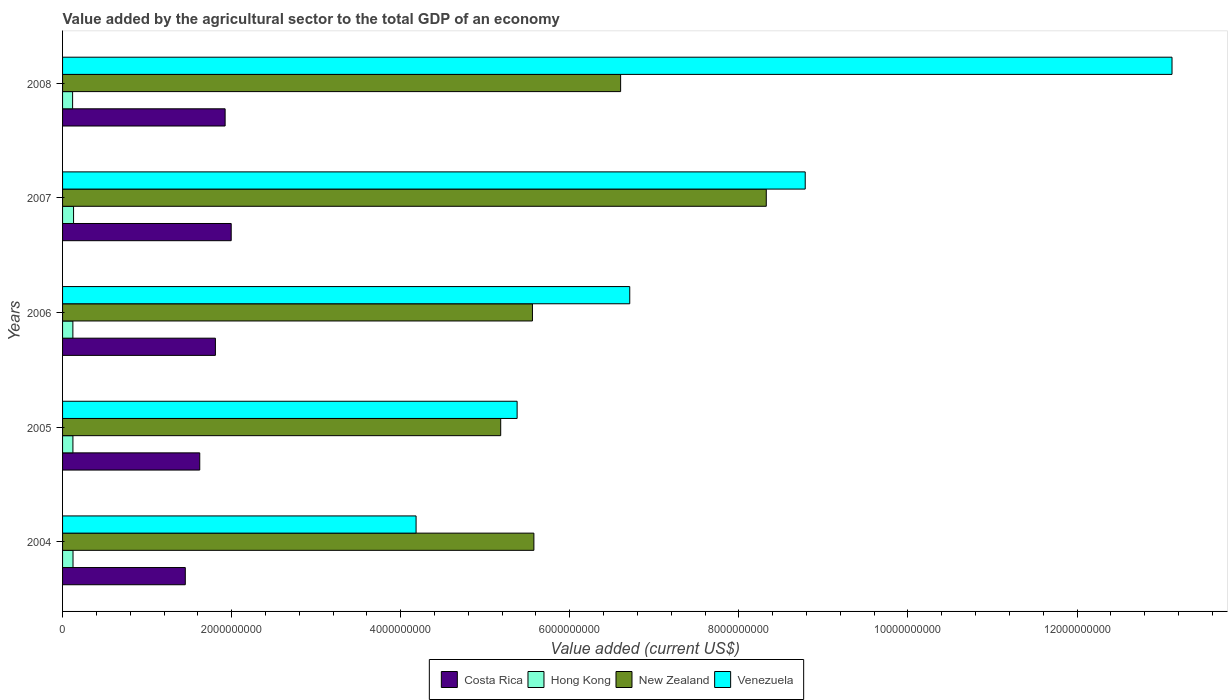Are the number of bars per tick equal to the number of legend labels?
Make the answer very short. Yes. Are the number of bars on each tick of the Y-axis equal?
Make the answer very short. Yes. How many bars are there on the 4th tick from the bottom?
Give a very brief answer. 4. What is the label of the 4th group of bars from the top?
Provide a short and direct response. 2005. What is the value added by the agricultural sector to the total GDP in Venezuela in 2008?
Make the answer very short. 1.31e+1. Across all years, what is the maximum value added by the agricultural sector to the total GDP in Hong Kong?
Your response must be concise. 1.30e+08. Across all years, what is the minimum value added by the agricultural sector to the total GDP in Hong Kong?
Keep it short and to the point. 1.19e+08. In which year was the value added by the agricultural sector to the total GDP in Costa Rica maximum?
Your answer should be very brief. 2007. In which year was the value added by the agricultural sector to the total GDP in Hong Kong minimum?
Your answer should be compact. 2008. What is the total value added by the agricultural sector to the total GDP in Venezuela in the graph?
Ensure brevity in your answer.  3.82e+1. What is the difference between the value added by the agricultural sector to the total GDP in Hong Kong in 2006 and that in 2007?
Keep it short and to the point. -8.19e+06. What is the difference between the value added by the agricultural sector to the total GDP in Costa Rica in 2004 and the value added by the agricultural sector to the total GDP in Venezuela in 2006?
Provide a short and direct response. -5.26e+09. What is the average value added by the agricultural sector to the total GDP in Costa Rica per year?
Your response must be concise. 1.76e+09. In the year 2007, what is the difference between the value added by the agricultural sector to the total GDP in Costa Rica and value added by the agricultural sector to the total GDP in Venezuela?
Your answer should be very brief. -6.79e+09. What is the ratio of the value added by the agricultural sector to the total GDP in Venezuela in 2004 to that in 2006?
Your response must be concise. 0.62. Is the value added by the agricultural sector to the total GDP in Costa Rica in 2006 less than that in 2007?
Give a very brief answer. Yes. What is the difference between the highest and the second highest value added by the agricultural sector to the total GDP in Venezuela?
Provide a succinct answer. 4.34e+09. What is the difference between the highest and the lowest value added by the agricultural sector to the total GDP in Hong Kong?
Ensure brevity in your answer.  1.13e+07. In how many years, is the value added by the agricultural sector to the total GDP in Costa Rica greater than the average value added by the agricultural sector to the total GDP in Costa Rica taken over all years?
Your response must be concise. 3. What does the 1st bar from the top in 2004 represents?
Your response must be concise. Venezuela. Are all the bars in the graph horizontal?
Keep it short and to the point. Yes. Does the graph contain grids?
Offer a very short reply. No. Where does the legend appear in the graph?
Offer a very short reply. Bottom center. How many legend labels are there?
Offer a terse response. 4. What is the title of the graph?
Provide a succinct answer. Value added by the agricultural sector to the total GDP of an economy. What is the label or title of the X-axis?
Your answer should be compact. Value added (current US$). What is the label or title of the Y-axis?
Offer a very short reply. Years. What is the Value added (current US$) of Costa Rica in 2004?
Give a very brief answer. 1.45e+09. What is the Value added (current US$) of Hong Kong in 2004?
Give a very brief answer. 1.24e+08. What is the Value added (current US$) in New Zealand in 2004?
Give a very brief answer. 5.58e+09. What is the Value added (current US$) of Venezuela in 2004?
Your answer should be very brief. 4.18e+09. What is the Value added (current US$) in Costa Rica in 2005?
Offer a terse response. 1.62e+09. What is the Value added (current US$) in Hong Kong in 2005?
Your answer should be compact. 1.23e+08. What is the Value added (current US$) of New Zealand in 2005?
Your answer should be compact. 5.18e+09. What is the Value added (current US$) of Venezuela in 2005?
Ensure brevity in your answer.  5.38e+09. What is the Value added (current US$) in Costa Rica in 2006?
Give a very brief answer. 1.81e+09. What is the Value added (current US$) of Hong Kong in 2006?
Your response must be concise. 1.22e+08. What is the Value added (current US$) in New Zealand in 2006?
Give a very brief answer. 5.56e+09. What is the Value added (current US$) of Venezuela in 2006?
Provide a succinct answer. 6.71e+09. What is the Value added (current US$) in Costa Rica in 2007?
Provide a short and direct response. 1.99e+09. What is the Value added (current US$) in Hong Kong in 2007?
Your answer should be very brief. 1.30e+08. What is the Value added (current US$) in New Zealand in 2007?
Give a very brief answer. 8.32e+09. What is the Value added (current US$) of Venezuela in 2007?
Your answer should be compact. 8.79e+09. What is the Value added (current US$) in Costa Rica in 2008?
Give a very brief answer. 1.92e+09. What is the Value added (current US$) in Hong Kong in 2008?
Ensure brevity in your answer.  1.19e+08. What is the Value added (current US$) of New Zealand in 2008?
Ensure brevity in your answer.  6.60e+09. What is the Value added (current US$) in Venezuela in 2008?
Provide a short and direct response. 1.31e+1. Across all years, what is the maximum Value added (current US$) in Costa Rica?
Your response must be concise. 1.99e+09. Across all years, what is the maximum Value added (current US$) in Hong Kong?
Your response must be concise. 1.30e+08. Across all years, what is the maximum Value added (current US$) in New Zealand?
Keep it short and to the point. 8.32e+09. Across all years, what is the maximum Value added (current US$) in Venezuela?
Offer a terse response. 1.31e+1. Across all years, what is the minimum Value added (current US$) in Costa Rica?
Offer a terse response. 1.45e+09. Across all years, what is the minimum Value added (current US$) in Hong Kong?
Give a very brief answer. 1.19e+08. Across all years, what is the minimum Value added (current US$) of New Zealand?
Your response must be concise. 5.18e+09. Across all years, what is the minimum Value added (current US$) in Venezuela?
Offer a terse response. 4.18e+09. What is the total Value added (current US$) of Costa Rica in the graph?
Your answer should be compact. 8.80e+09. What is the total Value added (current US$) in Hong Kong in the graph?
Keep it short and to the point. 6.17e+08. What is the total Value added (current US$) of New Zealand in the graph?
Offer a terse response. 3.12e+1. What is the total Value added (current US$) in Venezuela in the graph?
Your answer should be compact. 3.82e+1. What is the difference between the Value added (current US$) in Costa Rica in 2004 and that in 2005?
Ensure brevity in your answer.  -1.71e+08. What is the difference between the Value added (current US$) of Hong Kong in 2004 and that in 2005?
Ensure brevity in your answer.  1.12e+06. What is the difference between the Value added (current US$) of New Zealand in 2004 and that in 2005?
Your response must be concise. 3.93e+08. What is the difference between the Value added (current US$) in Venezuela in 2004 and that in 2005?
Ensure brevity in your answer.  -1.20e+09. What is the difference between the Value added (current US$) in Costa Rica in 2004 and that in 2006?
Provide a succinct answer. -3.56e+08. What is the difference between the Value added (current US$) in Hong Kong in 2004 and that in 2006?
Make the answer very short. 1.74e+06. What is the difference between the Value added (current US$) of New Zealand in 2004 and that in 2006?
Provide a short and direct response. 1.70e+07. What is the difference between the Value added (current US$) of Venezuela in 2004 and that in 2006?
Provide a succinct answer. -2.53e+09. What is the difference between the Value added (current US$) in Costa Rica in 2004 and that in 2007?
Give a very brief answer. -5.43e+08. What is the difference between the Value added (current US$) of Hong Kong in 2004 and that in 2007?
Offer a terse response. -6.45e+06. What is the difference between the Value added (current US$) of New Zealand in 2004 and that in 2007?
Make the answer very short. -2.75e+09. What is the difference between the Value added (current US$) of Venezuela in 2004 and that in 2007?
Keep it short and to the point. -4.60e+09. What is the difference between the Value added (current US$) in Costa Rica in 2004 and that in 2008?
Make the answer very short. -4.71e+08. What is the difference between the Value added (current US$) of Hong Kong in 2004 and that in 2008?
Your response must be concise. 4.86e+06. What is the difference between the Value added (current US$) in New Zealand in 2004 and that in 2008?
Offer a very short reply. -1.03e+09. What is the difference between the Value added (current US$) in Venezuela in 2004 and that in 2008?
Give a very brief answer. -8.94e+09. What is the difference between the Value added (current US$) of Costa Rica in 2005 and that in 2006?
Provide a succinct answer. -1.85e+08. What is the difference between the Value added (current US$) in Hong Kong in 2005 and that in 2006?
Offer a very short reply. 6.23e+05. What is the difference between the Value added (current US$) in New Zealand in 2005 and that in 2006?
Ensure brevity in your answer.  -3.76e+08. What is the difference between the Value added (current US$) in Venezuela in 2005 and that in 2006?
Make the answer very short. -1.33e+09. What is the difference between the Value added (current US$) of Costa Rica in 2005 and that in 2007?
Ensure brevity in your answer.  -3.72e+08. What is the difference between the Value added (current US$) of Hong Kong in 2005 and that in 2007?
Offer a terse response. -7.57e+06. What is the difference between the Value added (current US$) of New Zealand in 2005 and that in 2007?
Keep it short and to the point. -3.14e+09. What is the difference between the Value added (current US$) of Venezuela in 2005 and that in 2007?
Offer a terse response. -3.41e+09. What is the difference between the Value added (current US$) of Costa Rica in 2005 and that in 2008?
Keep it short and to the point. -3.00e+08. What is the difference between the Value added (current US$) in Hong Kong in 2005 and that in 2008?
Give a very brief answer. 3.75e+06. What is the difference between the Value added (current US$) of New Zealand in 2005 and that in 2008?
Provide a succinct answer. -1.42e+09. What is the difference between the Value added (current US$) in Venezuela in 2005 and that in 2008?
Your answer should be compact. -7.75e+09. What is the difference between the Value added (current US$) of Costa Rica in 2006 and that in 2007?
Keep it short and to the point. -1.87e+08. What is the difference between the Value added (current US$) of Hong Kong in 2006 and that in 2007?
Keep it short and to the point. -8.19e+06. What is the difference between the Value added (current US$) of New Zealand in 2006 and that in 2007?
Provide a short and direct response. -2.77e+09. What is the difference between the Value added (current US$) of Venezuela in 2006 and that in 2007?
Make the answer very short. -2.08e+09. What is the difference between the Value added (current US$) in Costa Rica in 2006 and that in 2008?
Make the answer very short. -1.15e+08. What is the difference between the Value added (current US$) in Hong Kong in 2006 and that in 2008?
Your answer should be compact. 3.12e+06. What is the difference between the Value added (current US$) in New Zealand in 2006 and that in 2008?
Your response must be concise. -1.04e+09. What is the difference between the Value added (current US$) in Venezuela in 2006 and that in 2008?
Your answer should be very brief. -6.41e+09. What is the difference between the Value added (current US$) of Costa Rica in 2007 and that in 2008?
Provide a succinct answer. 7.20e+07. What is the difference between the Value added (current US$) of Hong Kong in 2007 and that in 2008?
Offer a very short reply. 1.13e+07. What is the difference between the Value added (current US$) in New Zealand in 2007 and that in 2008?
Offer a very short reply. 1.72e+09. What is the difference between the Value added (current US$) of Venezuela in 2007 and that in 2008?
Your response must be concise. -4.34e+09. What is the difference between the Value added (current US$) in Costa Rica in 2004 and the Value added (current US$) in Hong Kong in 2005?
Keep it short and to the point. 1.33e+09. What is the difference between the Value added (current US$) in Costa Rica in 2004 and the Value added (current US$) in New Zealand in 2005?
Provide a succinct answer. -3.73e+09. What is the difference between the Value added (current US$) of Costa Rica in 2004 and the Value added (current US$) of Venezuela in 2005?
Provide a short and direct response. -3.93e+09. What is the difference between the Value added (current US$) of Hong Kong in 2004 and the Value added (current US$) of New Zealand in 2005?
Offer a terse response. -5.06e+09. What is the difference between the Value added (current US$) in Hong Kong in 2004 and the Value added (current US$) in Venezuela in 2005?
Offer a very short reply. -5.25e+09. What is the difference between the Value added (current US$) in New Zealand in 2004 and the Value added (current US$) in Venezuela in 2005?
Ensure brevity in your answer.  1.98e+08. What is the difference between the Value added (current US$) of Costa Rica in 2004 and the Value added (current US$) of Hong Kong in 2006?
Offer a terse response. 1.33e+09. What is the difference between the Value added (current US$) in Costa Rica in 2004 and the Value added (current US$) in New Zealand in 2006?
Keep it short and to the point. -4.11e+09. What is the difference between the Value added (current US$) of Costa Rica in 2004 and the Value added (current US$) of Venezuela in 2006?
Your answer should be very brief. -5.26e+09. What is the difference between the Value added (current US$) in Hong Kong in 2004 and the Value added (current US$) in New Zealand in 2006?
Ensure brevity in your answer.  -5.43e+09. What is the difference between the Value added (current US$) of Hong Kong in 2004 and the Value added (current US$) of Venezuela in 2006?
Give a very brief answer. -6.59e+09. What is the difference between the Value added (current US$) of New Zealand in 2004 and the Value added (current US$) of Venezuela in 2006?
Keep it short and to the point. -1.13e+09. What is the difference between the Value added (current US$) in Costa Rica in 2004 and the Value added (current US$) in Hong Kong in 2007?
Offer a terse response. 1.32e+09. What is the difference between the Value added (current US$) in Costa Rica in 2004 and the Value added (current US$) in New Zealand in 2007?
Make the answer very short. -6.87e+09. What is the difference between the Value added (current US$) of Costa Rica in 2004 and the Value added (current US$) of Venezuela in 2007?
Give a very brief answer. -7.33e+09. What is the difference between the Value added (current US$) in Hong Kong in 2004 and the Value added (current US$) in New Zealand in 2007?
Offer a terse response. -8.20e+09. What is the difference between the Value added (current US$) in Hong Kong in 2004 and the Value added (current US$) in Venezuela in 2007?
Provide a short and direct response. -8.66e+09. What is the difference between the Value added (current US$) of New Zealand in 2004 and the Value added (current US$) of Venezuela in 2007?
Provide a short and direct response. -3.21e+09. What is the difference between the Value added (current US$) in Costa Rica in 2004 and the Value added (current US$) in Hong Kong in 2008?
Offer a terse response. 1.33e+09. What is the difference between the Value added (current US$) of Costa Rica in 2004 and the Value added (current US$) of New Zealand in 2008?
Your answer should be compact. -5.15e+09. What is the difference between the Value added (current US$) in Costa Rica in 2004 and the Value added (current US$) in Venezuela in 2008?
Your response must be concise. -1.17e+1. What is the difference between the Value added (current US$) of Hong Kong in 2004 and the Value added (current US$) of New Zealand in 2008?
Make the answer very short. -6.48e+09. What is the difference between the Value added (current US$) in Hong Kong in 2004 and the Value added (current US$) in Venezuela in 2008?
Give a very brief answer. -1.30e+1. What is the difference between the Value added (current US$) in New Zealand in 2004 and the Value added (current US$) in Venezuela in 2008?
Keep it short and to the point. -7.55e+09. What is the difference between the Value added (current US$) of Costa Rica in 2005 and the Value added (current US$) of Hong Kong in 2006?
Your answer should be very brief. 1.50e+09. What is the difference between the Value added (current US$) of Costa Rica in 2005 and the Value added (current US$) of New Zealand in 2006?
Offer a very short reply. -3.94e+09. What is the difference between the Value added (current US$) in Costa Rica in 2005 and the Value added (current US$) in Venezuela in 2006?
Your answer should be very brief. -5.09e+09. What is the difference between the Value added (current US$) of Hong Kong in 2005 and the Value added (current US$) of New Zealand in 2006?
Your answer should be very brief. -5.44e+09. What is the difference between the Value added (current US$) of Hong Kong in 2005 and the Value added (current US$) of Venezuela in 2006?
Offer a terse response. -6.59e+09. What is the difference between the Value added (current US$) in New Zealand in 2005 and the Value added (current US$) in Venezuela in 2006?
Your answer should be compact. -1.53e+09. What is the difference between the Value added (current US$) of Costa Rica in 2005 and the Value added (current US$) of Hong Kong in 2007?
Keep it short and to the point. 1.49e+09. What is the difference between the Value added (current US$) of Costa Rica in 2005 and the Value added (current US$) of New Zealand in 2007?
Your answer should be compact. -6.70e+09. What is the difference between the Value added (current US$) in Costa Rica in 2005 and the Value added (current US$) in Venezuela in 2007?
Provide a succinct answer. -7.16e+09. What is the difference between the Value added (current US$) in Hong Kong in 2005 and the Value added (current US$) in New Zealand in 2007?
Offer a terse response. -8.20e+09. What is the difference between the Value added (current US$) in Hong Kong in 2005 and the Value added (current US$) in Venezuela in 2007?
Your answer should be very brief. -8.66e+09. What is the difference between the Value added (current US$) in New Zealand in 2005 and the Value added (current US$) in Venezuela in 2007?
Make the answer very short. -3.60e+09. What is the difference between the Value added (current US$) in Costa Rica in 2005 and the Value added (current US$) in Hong Kong in 2008?
Your answer should be compact. 1.50e+09. What is the difference between the Value added (current US$) of Costa Rica in 2005 and the Value added (current US$) of New Zealand in 2008?
Keep it short and to the point. -4.98e+09. What is the difference between the Value added (current US$) of Costa Rica in 2005 and the Value added (current US$) of Venezuela in 2008?
Provide a short and direct response. -1.15e+1. What is the difference between the Value added (current US$) in Hong Kong in 2005 and the Value added (current US$) in New Zealand in 2008?
Give a very brief answer. -6.48e+09. What is the difference between the Value added (current US$) of Hong Kong in 2005 and the Value added (current US$) of Venezuela in 2008?
Ensure brevity in your answer.  -1.30e+1. What is the difference between the Value added (current US$) in New Zealand in 2005 and the Value added (current US$) in Venezuela in 2008?
Your answer should be compact. -7.94e+09. What is the difference between the Value added (current US$) in Costa Rica in 2006 and the Value added (current US$) in Hong Kong in 2007?
Keep it short and to the point. 1.68e+09. What is the difference between the Value added (current US$) of Costa Rica in 2006 and the Value added (current US$) of New Zealand in 2007?
Make the answer very short. -6.52e+09. What is the difference between the Value added (current US$) of Costa Rica in 2006 and the Value added (current US$) of Venezuela in 2007?
Offer a terse response. -6.98e+09. What is the difference between the Value added (current US$) in Hong Kong in 2006 and the Value added (current US$) in New Zealand in 2007?
Give a very brief answer. -8.20e+09. What is the difference between the Value added (current US$) of Hong Kong in 2006 and the Value added (current US$) of Venezuela in 2007?
Make the answer very short. -8.66e+09. What is the difference between the Value added (current US$) of New Zealand in 2006 and the Value added (current US$) of Venezuela in 2007?
Your answer should be very brief. -3.23e+09. What is the difference between the Value added (current US$) of Costa Rica in 2006 and the Value added (current US$) of Hong Kong in 2008?
Offer a terse response. 1.69e+09. What is the difference between the Value added (current US$) of Costa Rica in 2006 and the Value added (current US$) of New Zealand in 2008?
Offer a terse response. -4.79e+09. What is the difference between the Value added (current US$) in Costa Rica in 2006 and the Value added (current US$) in Venezuela in 2008?
Keep it short and to the point. -1.13e+1. What is the difference between the Value added (current US$) of Hong Kong in 2006 and the Value added (current US$) of New Zealand in 2008?
Provide a succinct answer. -6.48e+09. What is the difference between the Value added (current US$) of Hong Kong in 2006 and the Value added (current US$) of Venezuela in 2008?
Offer a terse response. -1.30e+1. What is the difference between the Value added (current US$) of New Zealand in 2006 and the Value added (current US$) of Venezuela in 2008?
Your answer should be compact. -7.57e+09. What is the difference between the Value added (current US$) of Costa Rica in 2007 and the Value added (current US$) of Hong Kong in 2008?
Your answer should be very brief. 1.88e+09. What is the difference between the Value added (current US$) in Costa Rica in 2007 and the Value added (current US$) in New Zealand in 2008?
Give a very brief answer. -4.61e+09. What is the difference between the Value added (current US$) in Costa Rica in 2007 and the Value added (current US$) in Venezuela in 2008?
Provide a succinct answer. -1.11e+1. What is the difference between the Value added (current US$) of Hong Kong in 2007 and the Value added (current US$) of New Zealand in 2008?
Offer a very short reply. -6.47e+09. What is the difference between the Value added (current US$) of Hong Kong in 2007 and the Value added (current US$) of Venezuela in 2008?
Keep it short and to the point. -1.30e+1. What is the difference between the Value added (current US$) in New Zealand in 2007 and the Value added (current US$) in Venezuela in 2008?
Provide a short and direct response. -4.80e+09. What is the average Value added (current US$) in Costa Rica per year?
Your response must be concise. 1.76e+09. What is the average Value added (current US$) of Hong Kong per year?
Offer a very short reply. 1.23e+08. What is the average Value added (current US$) of New Zealand per year?
Your answer should be very brief. 6.25e+09. What is the average Value added (current US$) in Venezuela per year?
Provide a short and direct response. 7.64e+09. In the year 2004, what is the difference between the Value added (current US$) in Costa Rica and Value added (current US$) in Hong Kong?
Give a very brief answer. 1.33e+09. In the year 2004, what is the difference between the Value added (current US$) of Costa Rica and Value added (current US$) of New Zealand?
Ensure brevity in your answer.  -4.12e+09. In the year 2004, what is the difference between the Value added (current US$) in Costa Rica and Value added (current US$) in Venezuela?
Offer a very short reply. -2.73e+09. In the year 2004, what is the difference between the Value added (current US$) of Hong Kong and Value added (current US$) of New Zealand?
Keep it short and to the point. -5.45e+09. In the year 2004, what is the difference between the Value added (current US$) in Hong Kong and Value added (current US$) in Venezuela?
Give a very brief answer. -4.06e+09. In the year 2004, what is the difference between the Value added (current US$) in New Zealand and Value added (current US$) in Venezuela?
Keep it short and to the point. 1.39e+09. In the year 2005, what is the difference between the Value added (current US$) of Costa Rica and Value added (current US$) of Hong Kong?
Offer a very short reply. 1.50e+09. In the year 2005, what is the difference between the Value added (current US$) of Costa Rica and Value added (current US$) of New Zealand?
Provide a short and direct response. -3.56e+09. In the year 2005, what is the difference between the Value added (current US$) in Costa Rica and Value added (current US$) in Venezuela?
Your answer should be compact. -3.75e+09. In the year 2005, what is the difference between the Value added (current US$) in Hong Kong and Value added (current US$) in New Zealand?
Your response must be concise. -5.06e+09. In the year 2005, what is the difference between the Value added (current US$) in Hong Kong and Value added (current US$) in Venezuela?
Provide a short and direct response. -5.25e+09. In the year 2005, what is the difference between the Value added (current US$) in New Zealand and Value added (current US$) in Venezuela?
Your response must be concise. -1.94e+08. In the year 2006, what is the difference between the Value added (current US$) in Costa Rica and Value added (current US$) in Hong Kong?
Keep it short and to the point. 1.69e+09. In the year 2006, what is the difference between the Value added (current US$) in Costa Rica and Value added (current US$) in New Zealand?
Your response must be concise. -3.75e+09. In the year 2006, what is the difference between the Value added (current US$) in Costa Rica and Value added (current US$) in Venezuela?
Provide a short and direct response. -4.90e+09. In the year 2006, what is the difference between the Value added (current US$) in Hong Kong and Value added (current US$) in New Zealand?
Your response must be concise. -5.44e+09. In the year 2006, what is the difference between the Value added (current US$) of Hong Kong and Value added (current US$) of Venezuela?
Provide a succinct answer. -6.59e+09. In the year 2006, what is the difference between the Value added (current US$) of New Zealand and Value added (current US$) of Venezuela?
Provide a short and direct response. -1.15e+09. In the year 2007, what is the difference between the Value added (current US$) in Costa Rica and Value added (current US$) in Hong Kong?
Offer a very short reply. 1.86e+09. In the year 2007, what is the difference between the Value added (current US$) in Costa Rica and Value added (current US$) in New Zealand?
Your answer should be compact. -6.33e+09. In the year 2007, what is the difference between the Value added (current US$) in Costa Rica and Value added (current US$) in Venezuela?
Provide a short and direct response. -6.79e+09. In the year 2007, what is the difference between the Value added (current US$) of Hong Kong and Value added (current US$) of New Zealand?
Give a very brief answer. -8.19e+09. In the year 2007, what is the difference between the Value added (current US$) in Hong Kong and Value added (current US$) in Venezuela?
Your answer should be compact. -8.65e+09. In the year 2007, what is the difference between the Value added (current US$) of New Zealand and Value added (current US$) of Venezuela?
Your response must be concise. -4.61e+08. In the year 2008, what is the difference between the Value added (current US$) in Costa Rica and Value added (current US$) in Hong Kong?
Your answer should be compact. 1.80e+09. In the year 2008, what is the difference between the Value added (current US$) in Costa Rica and Value added (current US$) in New Zealand?
Your response must be concise. -4.68e+09. In the year 2008, what is the difference between the Value added (current US$) of Costa Rica and Value added (current US$) of Venezuela?
Provide a succinct answer. -1.12e+1. In the year 2008, what is the difference between the Value added (current US$) in Hong Kong and Value added (current US$) in New Zealand?
Your answer should be very brief. -6.48e+09. In the year 2008, what is the difference between the Value added (current US$) of Hong Kong and Value added (current US$) of Venezuela?
Your answer should be very brief. -1.30e+1. In the year 2008, what is the difference between the Value added (current US$) in New Zealand and Value added (current US$) in Venezuela?
Your answer should be compact. -6.52e+09. What is the ratio of the Value added (current US$) of Costa Rica in 2004 to that in 2005?
Give a very brief answer. 0.89. What is the ratio of the Value added (current US$) of Hong Kong in 2004 to that in 2005?
Your answer should be very brief. 1.01. What is the ratio of the Value added (current US$) of New Zealand in 2004 to that in 2005?
Give a very brief answer. 1.08. What is the ratio of the Value added (current US$) of Venezuela in 2004 to that in 2005?
Provide a succinct answer. 0.78. What is the ratio of the Value added (current US$) in Costa Rica in 2004 to that in 2006?
Provide a succinct answer. 0.8. What is the ratio of the Value added (current US$) in Hong Kong in 2004 to that in 2006?
Your response must be concise. 1.01. What is the ratio of the Value added (current US$) in Venezuela in 2004 to that in 2006?
Provide a succinct answer. 0.62. What is the ratio of the Value added (current US$) of Costa Rica in 2004 to that in 2007?
Provide a succinct answer. 0.73. What is the ratio of the Value added (current US$) of Hong Kong in 2004 to that in 2007?
Your response must be concise. 0.95. What is the ratio of the Value added (current US$) in New Zealand in 2004 to that in 2007?
Give a very brief answer. 0.67. What is the ratio of the Value added (current US$) of Venezuela in 2004 to that in 2007?
Give a very brief answer. 0.48. What is the ratio of the Value added (current US$) in Costa Rica in 2004 to that in 2008?
Your answer should be compact. 0.76. What is the ratio of the Value added (current US$) of Hong Kong in 2004 to that in 2008?
Make the answer very short. 1.04. What is the ratio of the Value added (current US$) of New Zealand in 2004 to that in 2008?
Provide a succinct answer. 0.84. What is the ratio of the Value added (current US$) of Venezuela in 2004 to that in 2008?
Offer a terse response. 0.32. What is the ratio of the Value added (current US$) of Costa Rica in 2005 to that in 2006?
Your response must be concise. 0.9. What is the ratio of the Value added (current US$) in New Zealand in 2005 to that in 2006?
Give a very brief answer. 0.93. What is the ratio of the Value added (current US$) of Venezuela in 2005 to that in 2006?
Give a very brief answer. 0.8. What is the ratio of the Value added (current US$) of Costa Rica in 2005 to that in 2007?
Your response must be concise. 0.81. What is the ratio of the Value added (current US$) of Hong Kong in 2005 to that in 2007?
Offer a terse response. 0.94. What is the ratio of the Value added (current US$) of New Zealand in 2005 to that in 2007?
Your answer should be very brief. 0.62. What is the ratio of the Value added (current US$) in Venezuela in 2005 to that in 2007?
Offer a terse response. 0.61. What is the ratio of the Value added (current US$) in Costa Rica in 2005 to that in 2008?
Offer a very short reply. 0.84. What is the ratio of the Value added (current US$) of Hong Kong in 2005 to that in 2008?
Keep it short and to the point. 1.03. What is the ratio of the Value added (current US$) in New Zealand in 2005 to that in 2008?
Offer a very short reply. 0.79. What is the ratio of the Value added (current US$) in Venezuela in 2005 to that in 2008?
Make the answer very short. 0.41. What is the ratio of the Value added (current US$) of Costa Rica in 2006 to that in 2007?
Offer a very short reply. 0.91. What is the ratio of the Value added (current US$) of Hong Kong in 2006 to that in 2007?
Your answer should be compact. 0.94. What is the ratio of the Value added (current US$) of New Zealand in 2006 to that in 2007?
Ensure brevity in your answer.  0.67. What is the ratio of the Value added (current US$) of Venezuela in 2006 to that in 2007?
Make the answer very short. 0.76. What is the ratio of the Value added (current US$) in Costa Rica in 2006 to that in 2008?
Provide a succinct answer. 0.94. What is the ratio of the Value added (current US$) in Hong Kong in 2006 to that in 2008?
Offer a terse response. 1.03. What is the ratio of the Value added (current US$) of New Zealand in 2006 to that in 2008?
Keep it short and to the point. 0.84. What is the ratio of the Value added (current US$) of Venezuela in 2006 to that in 2008?
Keep it short and to the point. 0.51. What is the ratio of the Value added (current US$) of Costa Rica in 2007 to that in 2008?
Ensure brevity in your answer.  1.04. What is the ratio of the Value added (current US$) of Hong Kong in 2007 to that in 2008?
Offer a very short reply. 1.1. What is the ratio of the Value added (current US$) of New Zealand in 2007 to that in 2008?
Your answer should be compact. 1.26. What is the ratio of the Value added (current US$) of Venezuela in 2007 to that in 2008?
Keep it short and to the point. 0.67. What is the difference between the highest and the second highest Value added (current US$) of Costa Rica?
Provide a succinct answer. 7.20e+07. What is the difference between the highest and the second highest Value added (current US$) in Hong Kong?
Your response must be concise. 6.45e+06. What is the difference between the highest and the second highest Value added (current US$) of New Zealand?
Your answer should be compact. 1.72e+09. What is the difference between the highest and the second highest Value added (current US$) of Venezuela?
Provide a succinct answer. 4.34e+09. What is the difference between the highest and the lowest Value added (current US$) of Costa Rica?
Keep it short and to the point. 5.43e+08. What is the difference between the highest and the lowest Value added (current US$) in Hong Kong?
Provide a succinct answer. 1.13e+07. What is the difference between the highest and the lowest Value added (current US$) in New Zealand?
Offer a terse response. 3.14e+09. What is the difference between the highest and the lowest Value added (current US$) in Venezuela?
Your answer should be compact. 8.94e+09. 